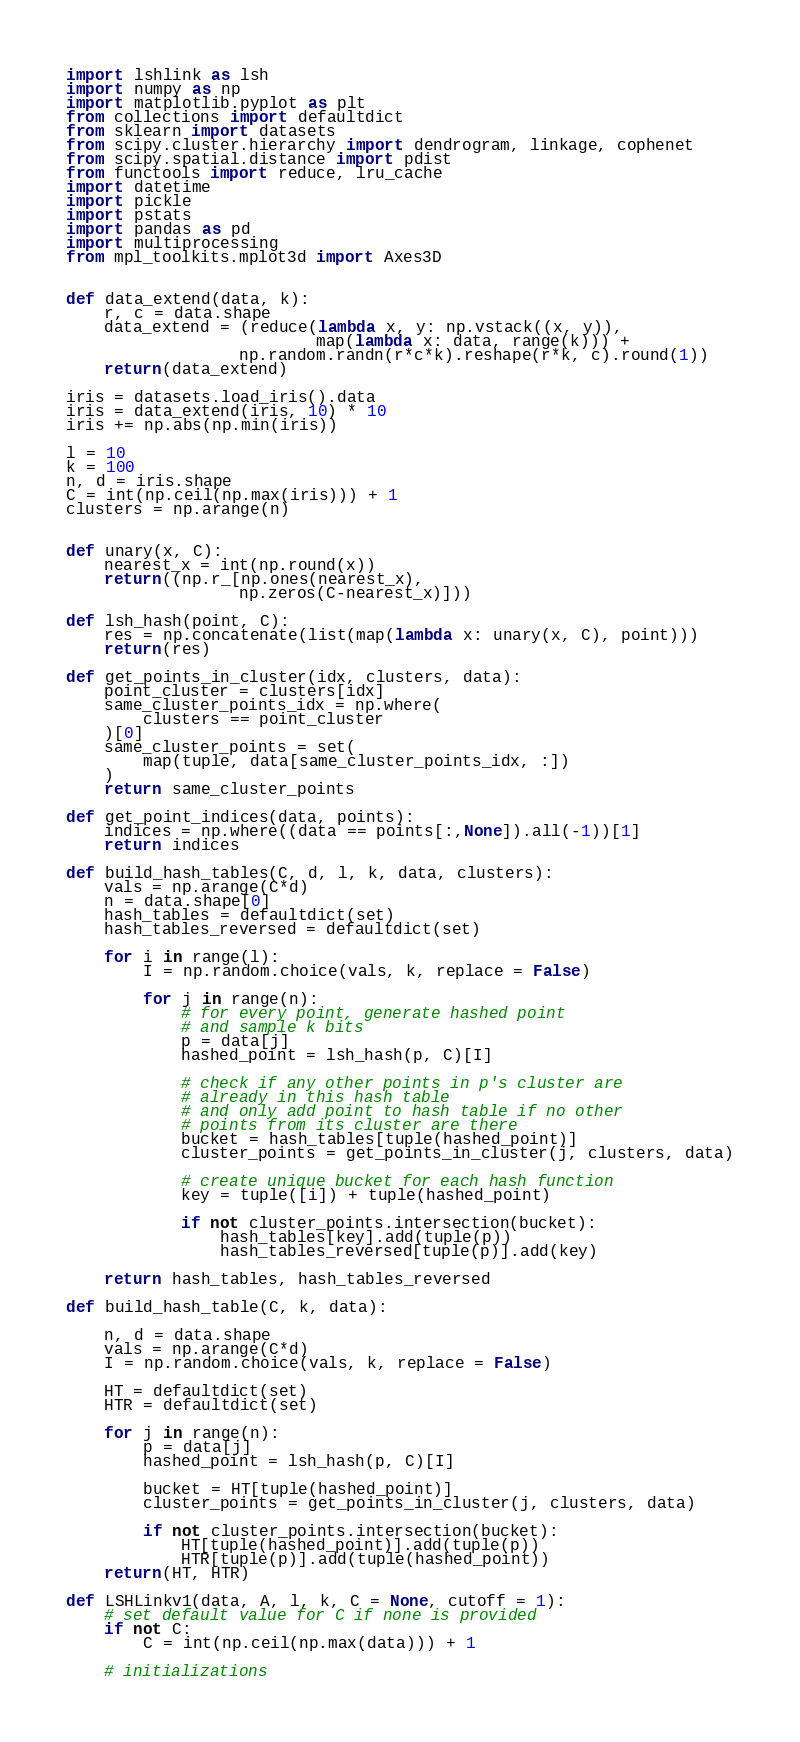Convert code to text. <code><loc_0><loc_0><loc_500><loc_500><_Python_>import lshlink as lsh
import numpy as np
import matplotlib.pyplot as plt
from collections import defaultdict
from sklearn import datasets
from scipy.cluster.hierarchy import dendrogram, linkage, cophenet
from scipy.spatial.distance import pdist
from functools import reduce, lru_cache
import datetime
import pickle
import pstats
import pandas as pd
import multiprocessing
from mpl_toolkits.mplot3d import Axes3D


def data_extend(data, k):
    r, c = data.shape
    data_extend = (reduce(lambda x, y: np.vstack((x, y)),
                          map(lambda x: data, range(k))) +
                  np.random.randn(r*c*k).reshape(r*k, c).round(1))
    return(data_extend)

iris = datasets.load_iris().data
iris = data_extend(iris, 10) * 10
iris += np.abs(np.min(iris))

l = 10
k = 100
n, d = iris.shape
C = int(np.ceil(np.max(iris))) + 1
clusters = np.arange(n)


def unary(x, C):
    nearest_x = int(np.round(x))
    return((np.r_[np.ones(nearest_x),
                  np.zeros(C-nearest_x)]))

def lsh_hash(point, C):
    res = np.concatenate(list(map(lambda x: unary(x, C), point)))
    return(res)

def get_points_in_cluster(idx, clusters, data):
    point_cluster = clusters[idx]
    same_cluster_points_idx = np.where(
        clusters == point_cluster
    )[0]
    same_cluster_points = set(
        map(tuple, data[same_cluster_points_idx, :])
    )
    return same_cluster_points

def get_point_indices(data, points):
    indices = np.where((data == points[:,None]).all(-1))[1]
    return indices

def build_hash_tables(C, d, l, k, data, clusters):
    vals = np.arange(C*d)
    n = data.shape[0]
    hash_tables = defaultdict(set)
    hash_tables_reversed = defaultdict(set)

    for i in range(l):
        I = np.random.choice(vals, k, replace = False)

        for j in range(n):
            # for every point, generate hashed point
            # and sample k bits
            p = data[j]
            hashed_point = lsh_hash(p, C)[I]
            
            # check if any other points in p's cluster are
            # already in this hash table
            # and only add point to hash table if no other
            # points from its cluster are there
            bucket = hash_tables[tuple(hashed_point)]
            cluster_points = get_points_in_cluster(j, clusters, data)
            
            # create unique bucket for each hash function
            key = tuple([i]) + tuple(hashed_point)

            if not cluster_points.intersection(bucket):
                hash_tables[key].add(tuple(p))
                hash_tables_reversed[tuple(p)].add(key)

    return hash_tables, hash_tables_reversed

def build_hash_table(C, k, data):
    
    n, d = data.shape
    vals = np.arange(C*d)
    I = np.random.choice(vals, k, replace = False)
    
    HT = defaultdict(set)
    HTR = defaultdict(set)

    for j in range(n):
        p = data[j]
        hashed_point = lsh_hash(p, C)[I]
        
        bucket = HT[tuple(hashed_point)]
        cluster_points = get_points_in_cluster(j, clusters, data)

        if not cluster_points.intersection(bucket):
            HT[tuple(hashed_point)].add(tuple(p))
            HTR[tuple(p)].add(tuple(hashed_point))
    return(HT, HTR)

def LSHLinkv1(data, A, l, k, C = None, cutoff = 1):
    # set default value for C if none is provided
    if not C:
        C = int(np.ceil(np.max(data))) + 1
    
    # initializations</code> 